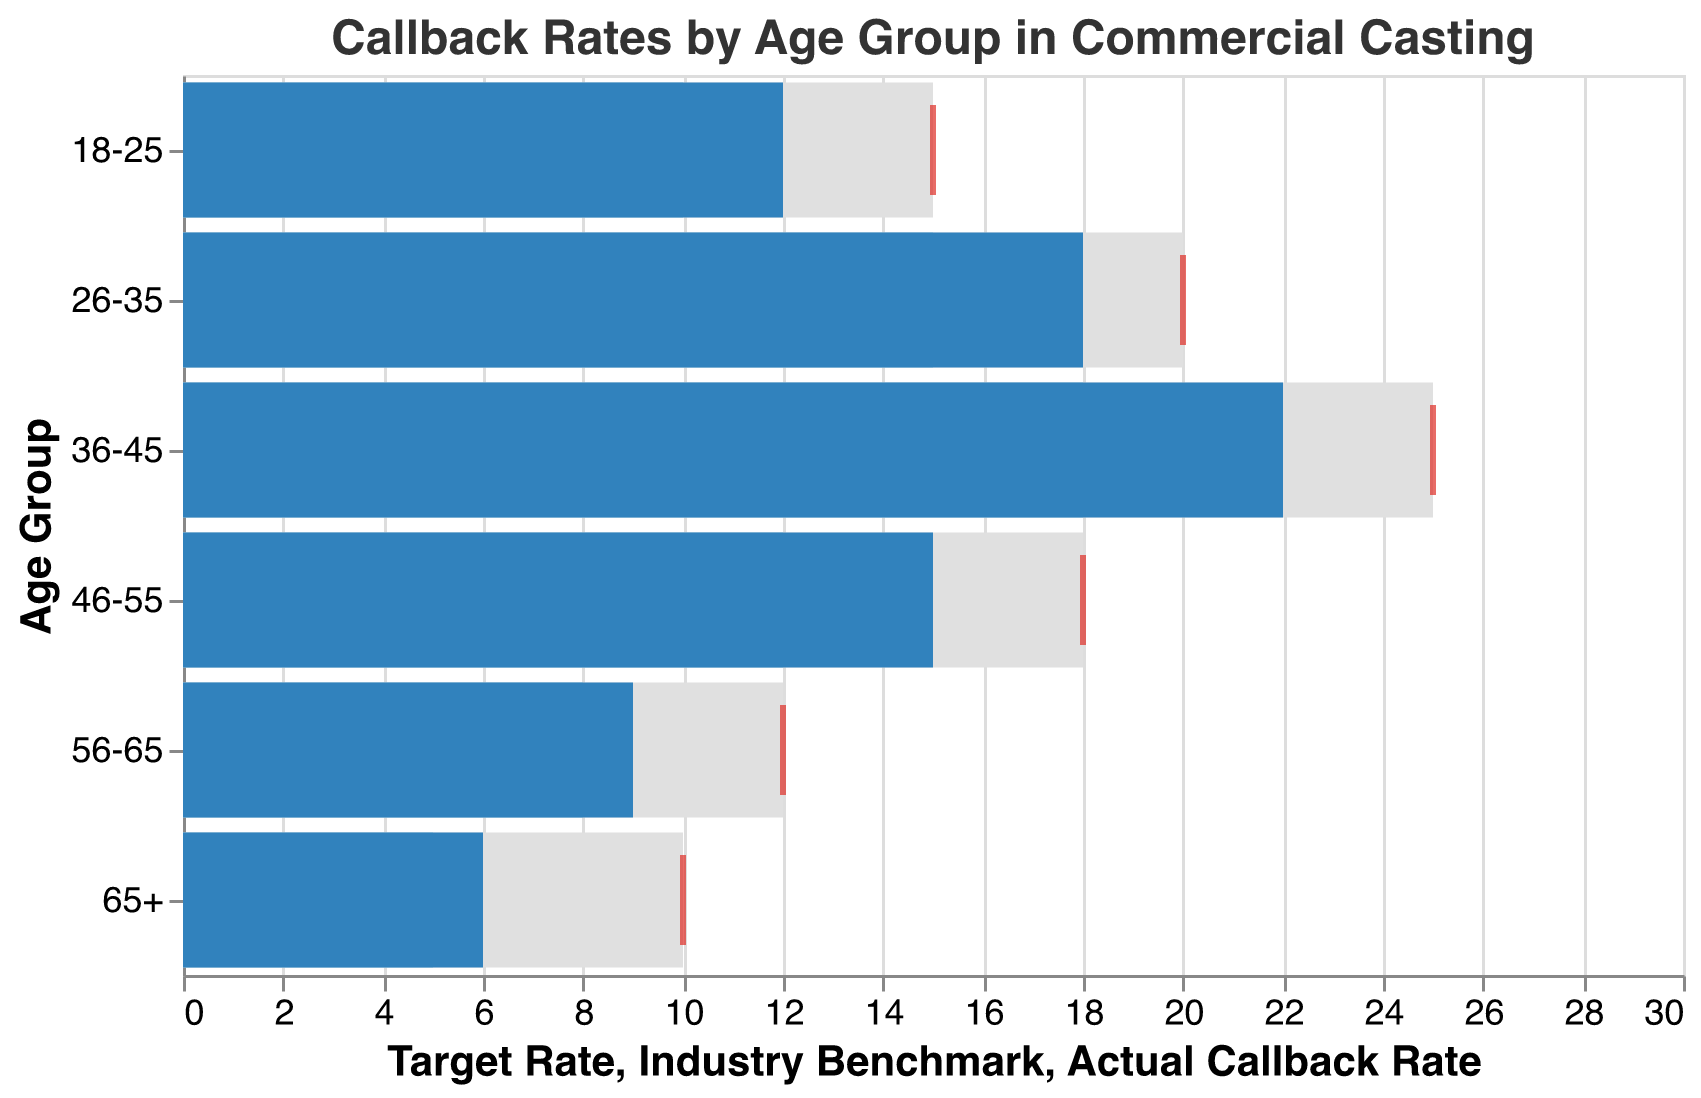How many age groups are represented in the figure? Count the total number of unique age groups listed on the y-axis.
Answer: 6 Which age group has the highest actual callback rate, and what is that rate? Identify the highest value under "Actual Callback Rate" and find the corresponding age group.
Answer: 36-45 with 22% How does the actual callback rate for the age group 26-35 compare to the industry benchmark for the same group? Look at the "Actual Callback Rate" and "Industry Benchmark" for the age group 26-35 and compare them.
Answer: The actual rate is higher (18% vs. 15%) What is the difference between the target rate and the actual callback rate for the age group 56-65? Subtract the "Actual Callback Rate" from the "Target Rate" for the 56-65 age group (12 - 9).
Answer: 3% Is there any age group where the actual callback rate exceeds the target rate? Compare each age group's "Actual Callback Rate" with its "Target Rate" to see if any actual values are higher.
Answer: No What is the average target rate across all age groups? Sum the target rates for all age groups and then divide by the number of groups (15+20+25+18+12+10) / 6.
Answer: 16.67% Which age group has the largest discrepancy between their actual callback rate and the industry benchmark? Calculate the difference between "Actual Callback Rate" and "Industry Benchmark" for each age group and identify the largest value.
Answer: 36-45 with a difference of 4% For the 46-55 age group, what percentage of the target rate is achieved by the actual callback rate? Divide the "Actual Callback Rate" by the "Target Rate" for the 46-55 group and multiply by 100 (15/18 * 100).
Answer: 83.33% Are all actual callback rates above the industry benchmarks for their respective age groups? Compare the "Actual Callback Rate" with the "Industry Benchmark" for each age group to see if all actual values are greater.
Answer: Yes What is the difference in the actual callback rate between the youngest (18-25) and oldest (65+) age groups? Subtract the "Actual Callback Rate" of the 65+ group from the 18-25 group (12 - 6).
Answer: 6% 